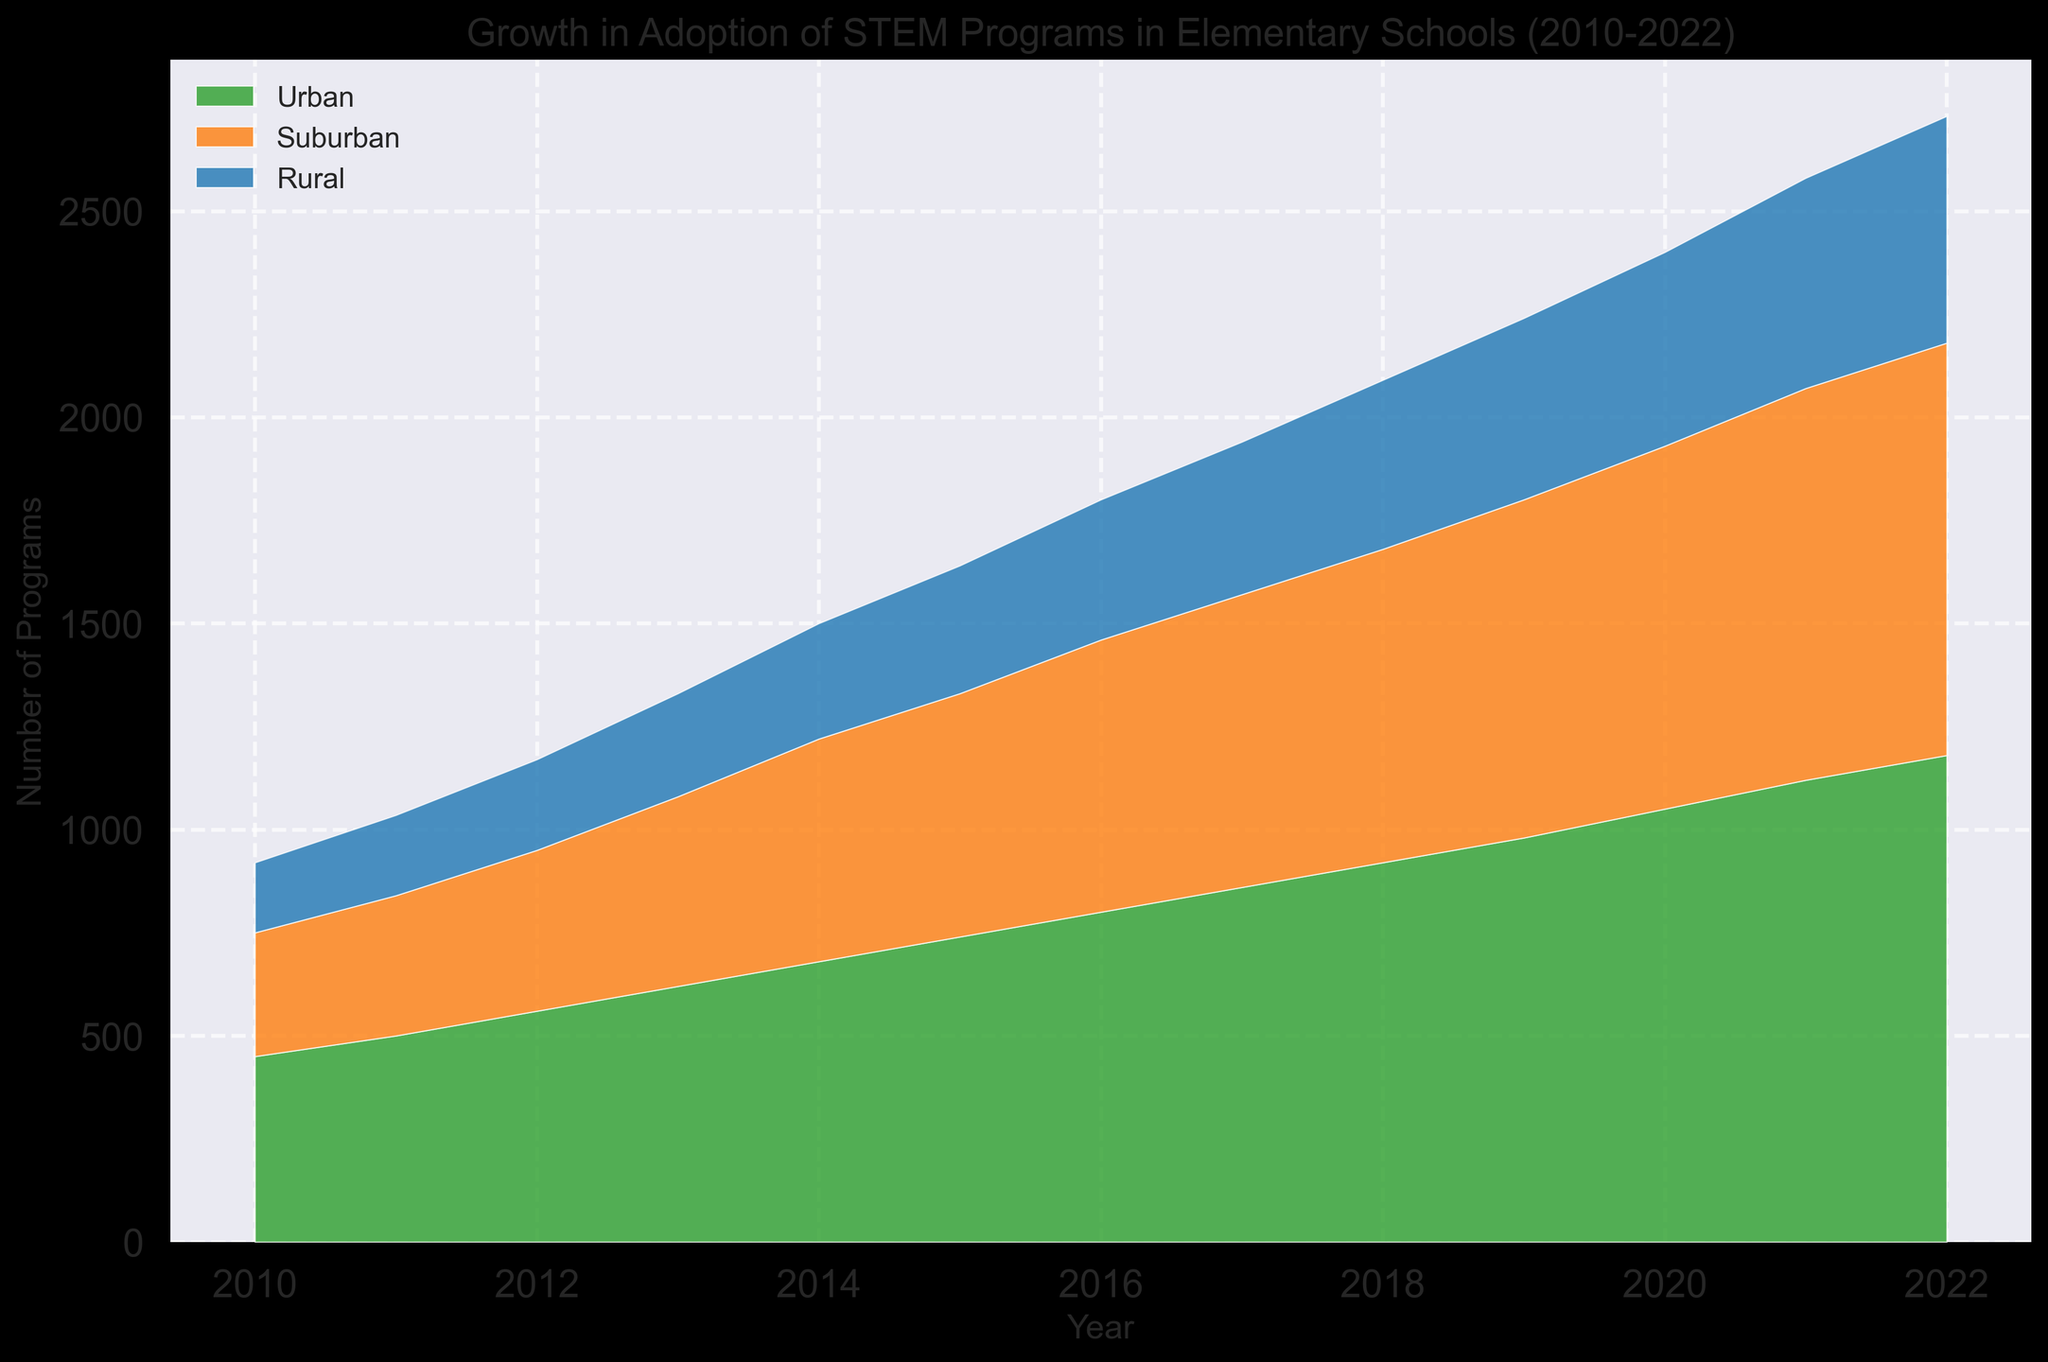Which area experienced the highest increase in STEM programs from 2010 to 2022? By examining the stacked area chart, we can see that the Urban area shows the greatest increase in height from 2010 to 2022 compared to Suburban and Rural areas. This indicates it had the highest increase in the number of STEM programs.
Answer: Urban What is the approximate total number of STEM programs in Urban areas in 2020? To find this, we look at the height of the Urban area segment in 2020. From the chart, this appears to be approximately 350 programs.
Answer: 350 In which year did Suburban areas surpass 300 STEM programs? By looking at the stacked area chart, the height of the Suburban segment surpasses 300 around 2016.
Answer: 2016 Which area had the least number of STEM programs in 2010? By observing the starting heights of each area segment in 2010, the Rural area is visibly the smallest, indicating it had the least number of programs.
Answer: Rural When did Rural areas first reach 200 STEM programs? From the area chart, the height of the Rural segment reaches 200 around 2021.
Answer: 2021 How did the number of Suburban STEM programs change from 2010 to 2014? The height of the Suburban segment increased from about 200 to 280, calculated as 280 - 200.
Answer: Increased by 80 What is the difference between the number of STEM programs in Urban and Rural areas in 2022? In 2022, the height for Urban areas is approximately 400 and Rural is around 340. The difference is 400 - 340.
Answer: 60 Which area shows the slowest growth in STEM programs overall? By observing the relative growth patterns, the Rural area shows the slowest progression in height over time.
Answer: Rural Throughout the period from 2010 to 2022, which of the three areas consistently has fewer programs than Suburban areas? By comparing the heights for each area, both Rural and Urban have certain periods with fewer programs, but Rural consistently has fewer programs than Suburban areas throughout the entire period.
Answer: Rural 